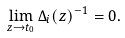<formula> <loc_0><loc_0><loc_500><loc_500>\lim _ { z \to t _ { 0 } } \Delta _ { i } ( z ) ^ { - 1 } = 0 .</formula> 